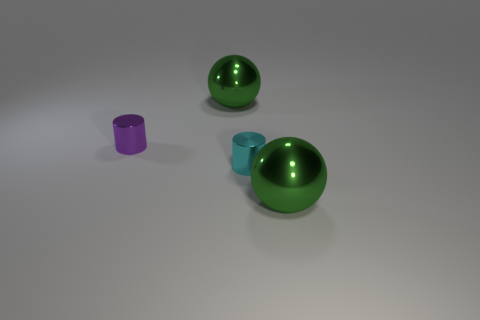Is the material of the object behind the tiny purple cylinder the same as the small object in front of the purple metal object?
Give a very brief answer. Yes. What number of yellow objects are either shiny cylinders or large balls?
Make the answer very short. 0. Are there more things that are right of the small cyan thing than large brown objects?
Make the answer very short. Yes. There is a cyan cylinder; what number of big green shiny things are right of it?
Your answer should be compact. 1. Are there any blue balls that have the same size as the cyan object?
Provide a short and direct response. No. What is the color of the other object that is the same shape as the small cyan metallic object?
Provide a short and direct response. Purple. There is a cylinder behind the cyan cylinder; is its size the same as the cyan object that is in front of the purple shiny cylinder?
Give a very brief answer. Yes. Are there any other metallic objects of the same shape as the tiny purple shiny object?
Your response must be concise. Yes. Are there the same number of tiny cylinders that are in front of the tiny cyan metal thing and tiny gray blocks?
Provide a short and direct response. Yes. Does the purple metal cylinder have the same size as the cylinder that is in front of the purple shiny cylinder?
Your response must be concise. Yes. 